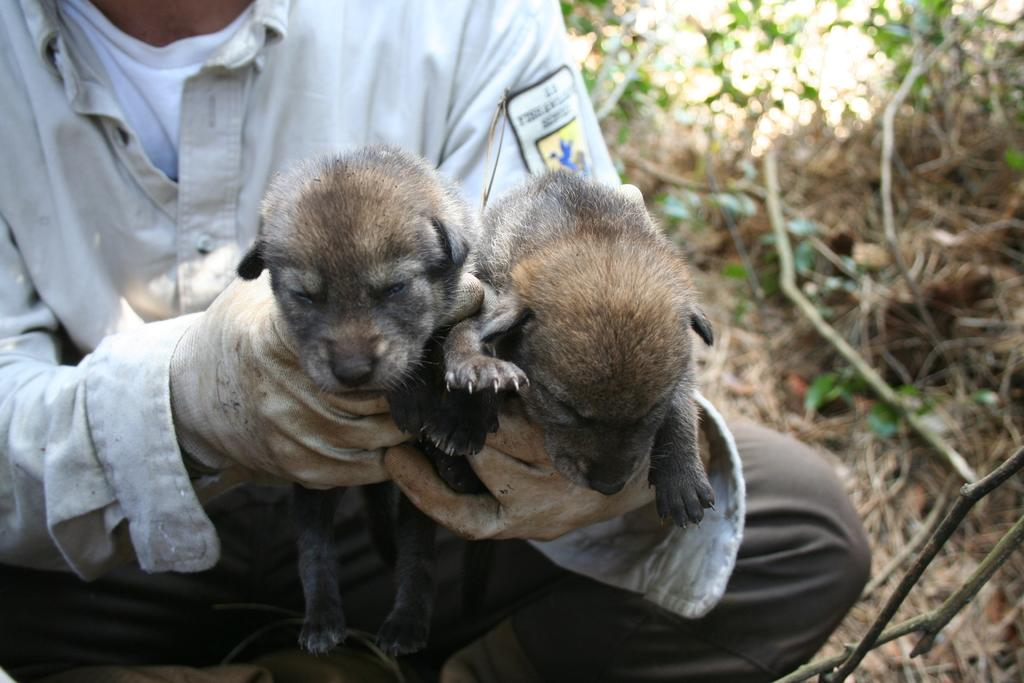Who or what is the main subject in the image? There is a person in the image. What is the person doing in the image? The person is holding animals in his hand. What can be seen in the background of the image? There are plants and dry grass in the background of the image. How many giants are visible in the image? There are no giants present in the image. Is there a girl in the image? The provided facts do not mention a girl, so we cannot confirm her presence in the image. What type of camera is being used to take the picture? The provided facts do not mention a camera, so we cannot determine the type of camera used to take the image. 